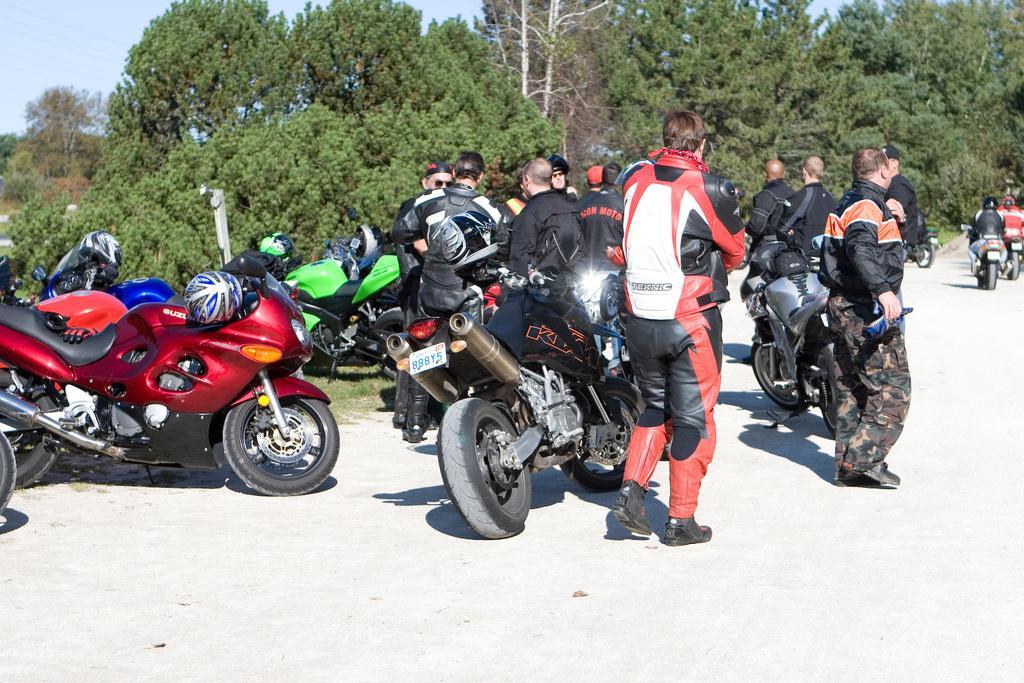How would you summarize this image in a sentence or two? In this image we can see persons standing on the road and motor vehicles beside them. In the background there are trees and sky. 